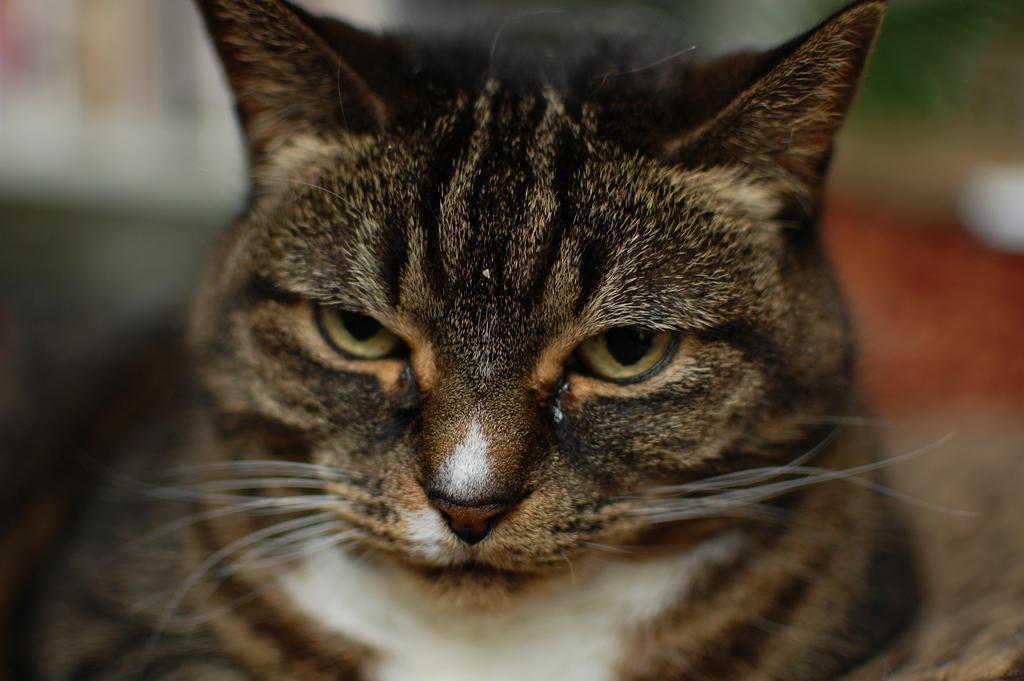In one or two sentences, can you explain what this image depicts? In this picture we can see the cat. 